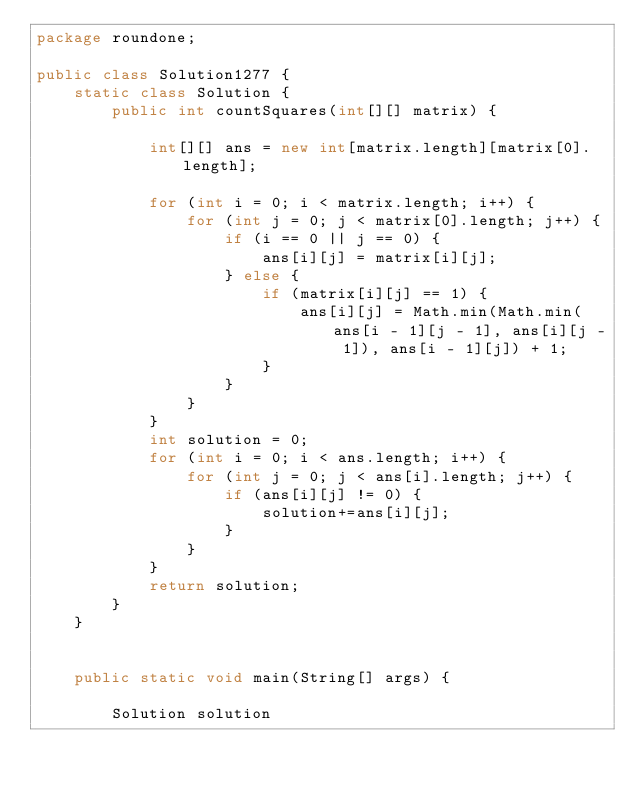<code> <loc_0><loc_0><loc_500><loc_500><_Java_>package roundone;

public class Solution1277 {
    static class Solution {
        public int countSquares(int[][] matrix) {

            int[][] ans = new int[matrix.length][matrix[0].length];

            for (int i = 0; i < matrix.length; i++) {
                for (int j = 0; j < matrix[0].length; j++) {
                    if (i == 0 || j == 0) {
                        ans[i][j] = matrix[i][j];
                    } else {
                        if (matrix[i][j] == 1) {
                            ans[i][j] = Math.min(Math.min(ans[i - 1][j - 1], ans[i][j - 1]), ans[i - 1][j]) + 1;
                        }
                    }
                }
            }
            int solution = 0;
            for (int i = 0; i < ans.length; i++) {
                for (int j = 0; j < ans[i].length; j++) {
                    if (ans[i][j] != 0) {
                        solution+=ans[i][j];
                    }
                }
            }
            return solution;
        }
    }


    public static void main(String[] args) {

        Solution solution</code> 